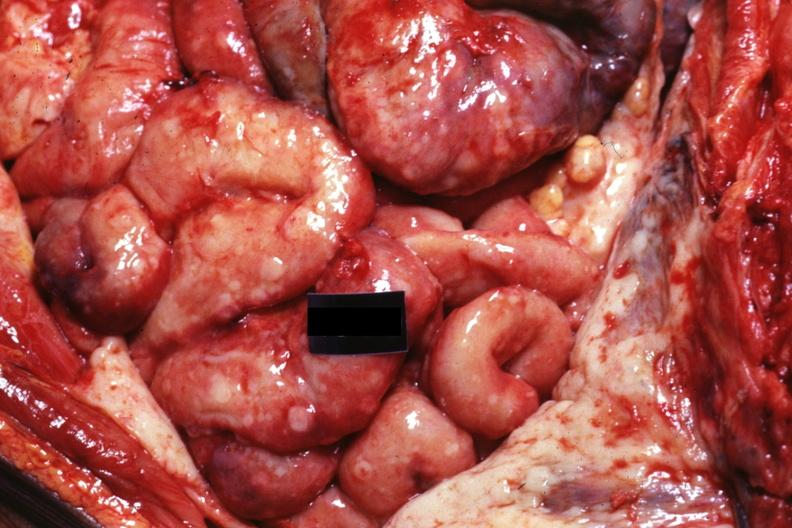what does this image show?
Answer the question using a single word or phrase. In situ natural color very good 